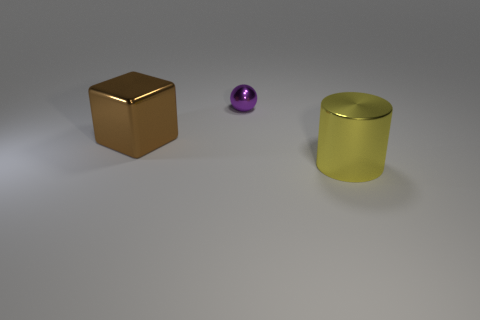Add 2 purple shiny spheres. How many objects exist? 5 Subtract 1 blocks. How many blocks are left? 0 Subtract all brown shiny objects. Subtract all metal spheres. How many objects are left? 1 Add 3 purple objects. How many purple objects are left? 4 Add 1 purple metallic spheres. How many purple metallic spheres exist? 2 Subtract 0 yellow cubes. How many objects are left? 3 Subtract all cylinders. How many objects are left? 2 Subtract all gray cylinders. Subtract all gray spheres. How many cylinders are left? 1 Subtract all cyan cubes. How many cyan balls are left? 0 